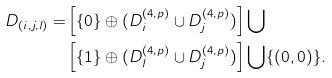<formula> <loc_0><loc_0><loc_500><loc_500>D _ { ( i , j , l ) } = & \left [ \{ 0 \} \oplus ( D _ { i } ^ { ( 4 , p ) } \cup D _ { j } ^ { ( 4 , p ) } ) \right ] \bigcup \\ & \left [ \{ 1 \} \oplus ( D _ { l } ^ { ( 4 , p ) } \cup D _ { j } ^ { ( 4 , p ) } ) \right ] \bigcup \{ ( 0 , 0 ) \} .</formula> 